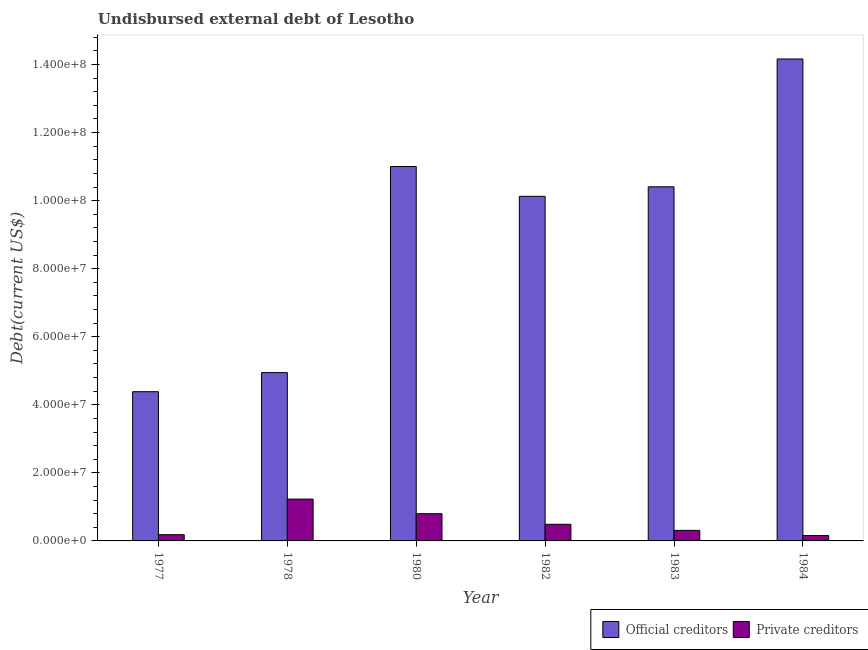Are the number of bars per tick equal to the number of legend labels?
Provide a succinct answer. Yes. Are the number of bars on each tick of the X-axis equal?
Your answer should be very brief. Yes. How many bars are there on the 6th tick from the left?
Provide a succinct answer. 2. What is the label of the 2nd group of bars from the left?
Give a very brief answer. 1978. What is the undisbursed external debt of official creditors in 1983?
Offer a terse response. 1.04e+08. Across all years, what is the maximum undisbursed external debt of official creditors?
Your answer should be compact. 1.42e+08. Across all years, what is the minimum undisbursed external debt of private creditors?
Offer a very short reply. 1.58e+06. In which year was the undisbursed external debt of private creditors maximum?
Your response must be concise. 1978. What is the total undisbursed external debt of private creditors in the graph?
Your answer should be compact. 3.17e+07. What is the difference between the undisbursed external debt of private creditors in 1978 and that in 1982?
Offer a very short reply. 7.40e+06. What is the difference between the undisbursed external debt of private creditors in 1980 and the undisbursed external debt of official creditors in 1982?
Give a very brief answer. 3.11e+06. What is the average undisbursed external debt of private creditors per year?
Offer a terse response. 5.28e+06. What is the ratio of the undisbursed external debt of official creditors in 1980 to that in 1984?
Provide a succinct answer. 0.78. Is the undisbursed external debt of private creditors in 1980 less than that in 1983?
Give a very brief answer. No. What is the difference between the highest and the second highest undisbursed external debt of private creditors?
Keep it short and to the point. 4.29e+06. What is the difference between the highest and the lowest undisbursed external debt of private creditors?
Your answer should be very brief. 1.07e+07. Is the sum of the undisbursed external debt of official creditors in 1983 and 1984 greater than the maximum undisbursed external debt of private creditors across all years?
Make the answer very short. Yes. What does the 1st bar from the left in 1982 represents?
Make the answer very short. Official creditors. What does the 2nd bar from the right in 1982 represents?
Keep it short and to the point. Official creditors. What is the difference between two consecutive major ticks on the Y-axis?
Make the answer very short. 2.00e+07. Are the values on the major ticks of Y-axis written in scientific E-notation?
Provide a succinct answer. Yes. Does the graph contain any zero values?
Give a very brief answer. No. Does the graph contain grids?
Your response must be concise. No. Where does the legend appear in the graph?
Make the answer very short. Bottom right. How many legend labels are there?
Your answer should be compact. 2. How are the legend labels stacked?
Provide a short and direct response. Horizontal. What is the title of the graph?
Ensure brevity in your answer.  Undisbursed external debt of Lesotho. What is the label or title of the Y-axis?
Your answer should be compact. Debt(current US$). What is the Debt(current US$) of Official creditors in 1977?
Your answer should be very brief. 4.39e+07. What is the Debt(current US$) of Private creditors in 1977?
Your response must be concise. 1.84e+06. What is the Debt(current US$) of Official creditors in 1978?
Provide a short and direct response. 4.95e+07. What is the Debt(current US$) of Private creditors in 1978?
Offer a very short reply. 1.23e+07. What is the Debt(current US$) in Official creditors in 1980?
Make the answer very short. 1.10e+08. What is the Debt(current US$) in Official creditors in 1982?
Provide a short and direct response. 1.01e+08. What is the Debt(current US$) of Private creditors in 1982?
Keep it short and to the point. 4.89e+06. What is the Debt(current US$) in Official creditors in 1983?
Make the answer very short. 1.04e+08. What is the Debt(current US$) of Private creditors in 1983?
Keep it short and to the point. 3.10e+06. What is the Debt(current US$) in Official creditors in 1984?
Your response must be concise. 1.42e+08. What is the Debt(current US$) in Private creditors in 1984?
Provide a short and direct response. 1.58e+06. Across all years, what is the maximum Debt(current US$) of Official creditors?
Provide a short and direct response. 1.42e+08. Across all years, what is the maximum Debt(current US$) of Private creditors?
Your answer should be compact. 1.23e+07. Across all years, what is the minimum Debt(current US$) in Official creditors?
Your response must be concise. 4.39e+07. Across all years, what is the minimum Debt(current US$) of Private creditors?
Offer a very short reply. 1.58e+06. What is the total Debt(current US$) in Official creditors in the graph?
Offer a terse response. 5.50e+08. What is the total Debt(current US$) of Private creditors in the graph?
Keep it short and to the point. 3.17e+07. What is the difference between the Debt(current US$) of Official creditors in 1977 and that in 1978?
Offer a terse response. -5.61e+06. What is the difference between the Debt(current US$) in Private creditors in 1977 and that in 1978?
Keep it short and to the point. -1.05e+07. What is the difference between the Debt(current US$) in Official creditors in 1977 and that in 1980?
Your response must be concise. -6.62e+07. What is the difference between the Debt(current US$) in Private creditors in 1977 and that in 1980?
Provide a succinct answer. -6.16e+06. What is the difference between the Debt(current US$) in Official creditors in 1977 and that in 1982?
Your answer should be very brief. -5.74e+07. What is the difference between the Debt(current US$) in Private creditors in 1977 and that in 1982?
Your response must be concise. -3.05e+06. What is the difference between the Debt(current US$) in Official creditors in 1977 and that in 1983?
Offer a very short reply. -6.02e+07. What is the difference between the Debt(current US$) in Private creditors in 1977 and that in 1983?
Offer a terse response. -1.26e+06. What is the difference between the Debt(current US$) in Official creditors in 1977 and that in 1984?
Offer a terse response. -9.78e+07. What is the difference between the Debt(current US$) of Private creditors in 1977 and that in 1984?
Keep it short and to the point. 2.59e+05. What is the difference between the Debt(current US$) in Official creditors in 1978 and that in 1980?
Provide a short and direct response. -6.06e+07. What is the difference between the Debt(current US$) in Private creditors in 1978 and that in 1980?
Keep it short and to the point. 4.29e+06. What is the difference between the Debt(current US$) in Official creditors in 1978 and that in 1982?
Give a very brief answer. -5.18e+07. What is the difference between the Debt(current US$) in Private creditors in 1978 and that in 1982?
Provide a short and direct response. 7.40e+06. What is the difference between the Debt(current US$) in Official creditors in 1978 and that in 1983?
Ensure brevity in your answer.  -5.46e+07. What is the difference between the Debt(current US$) of Private creditors in 1978 and that in 1983?
Provide a succinct answer. 9.19e+06. What is the difference between the Debt(current US$) of Official creditors in 1978 and that in 1984?
Your answer should be very brief. -9.22e+07. What is the difference between the Debt(current US$) of Private creditors in 1978 and that in 1984?
Provide a succinct answer. 1.07e+07. What is the difference between the Debt(current US$) of Official creditors in 1980 and that in 1982?
Offer a terse response. 8.77e+06. What is the difference between the Debt(current US$) in Private creditors in 1980 and that in 1982?
Offer a terse response. 3.11e+06. What is the difference between the Debt(current US$) of Official creditors in 1980 and that in 1983?
Provide a succinct answer. 5.97e+06. What is the difference between the Debt(current US$) of Private creditors in 1980 and that in 1983?
Offer a very short reply. 4.90e+06. What is the difference between the Debt(current US$) in Official creditors in 1980 and that in 1984?
Your answer should be very brief. -3.16e+07. What is the difference between the Debt(current US$) in Private creditors in 1980 and that in 1984?
Ensure brevity in your answer.  6.42e+06. What is the difference between the Debt(current US$) in Official creditors in 1982 and that in 1983?
Give a very brief answer. -2.80e+06. What is the difference between the Debt(current US$) in Private creditors in 1982 and that in 1983?
Provide a short and direct response. 1.79e+06. What is the difference between the Debt(current US$) in Official creditors in 1982 and that in 1984?
Your answer should be compact. -4.04e+07. What is the difference between the Debt(current US$) of Private creditors in 1982 and that in 1984?
Make the answer very short. 3.31e+06. What is the difference between the Debt(current US$) of Official creditors in 1983 and that in 1984?
Your answer should be very brief. -3.76e+07. What is the difference between the Debt(current US$) of Private creditors in 1983 and that in 1984?
Ensure brevity in your answer.  1.52e+06. What is the difference between the Debt(current US$) in Official creditors in 1977 and the Debt(current US$) in Private creditors in 1978?
Offer a terse response. 3.16e+07. What is the difference between the Debt(current US$) of Official creditors in 1977 and the Debt(current US$) of Private creditors in 1980?
Your answer should be very brief. 3.59e+07. What is the difference between the Debt(current US$) of Official creditors in 1977 and the Debt(current US$) of Private creditors in 1982?
Give a very brief answer. 3.90e+07. What is the difference between the Debt(current US$) in Official creditors in 1977 and the Debt(current US$) in Private creditors in 1983?
Ensure brevity in your answer.  4.08e+07. What is the difference between the Debt(current US$) in Official creditors in 1977 and the Debt(current US$) in Private creditors in 1984?
Provide a succinct answer. 4.23e+07. What is the difference between the Debt(current US$) of Official creditors in 1978 and the Debt(current US$) of Private creditors in 1980?
Your answer should be very brief. 4.15e+07. What is the difference between the Debt(current US$) of Official creditors in 1978 and the Debt(current US$) of Private creditors in 1982?
Your answer should be very brief. 4.46e+07. What is the difference between the Debt(current US$) of Official creditors in 1978 and the Debt(current US$) of Private creditors in 1983?
Ensure brevity in your answer.  4.64e+07. What is the difference between the Debt(current US$) in Official creditors in 1978 and the Debt(current US$) in Private creditors in 1984?
Your answer should be very brief. 4.79e+07. What is the difference between the Debt(current US$) in Official creditors in 1980 and the Debt(current US$) in Private creditors in 1982?
Offer a very short reply. 1.05e+08. What is the difference between the Debt(current US$) in Official creditors in 1980 and the Debt(current US$) in Private creditors in 1983?
Offer a terse response. 1.07e+08. What is the difference between the Debt(current US$) in Official creditors in 1980 and the Debt(current US$) in Private creditors in 1984?
Make the answer very short. 1.08e+08. What is the difference between the Debt(current US$) of Official creditors in 1982 and the Debt(current US$) of Private creditors in 1983?
Ensure brevity in your answer.  9.82e+07. What is the difference between the Debt(current US$) in Official creditors in 1982 and the Debt(current US$) in Private creditors in 1984?
Provide a short and direct response. 9.97e+07. What is the difference between the Debt(current US$) of Official creditors in 1983 and the Debt(current US$) of Private creditors in 1984?
Your answer should be very brief. 1.02e+08. What is the average Debt(current US$) in Official creditors per year?
Provide a short and direct response. 9.17e+07. What is the average Debt(current US$) in Private creditors per year?
Make the answer very short. 5.28e+06. In the year 1977, what is the difference between the Debt(current US$) in Official creditors and Debt(current US$) in Private creditors?
Keep it short and to the point. 4.20e+07. In the year 1978, what is the difference between the Debt(current US$) in Official creditors and Debt(current US$) in Private creditors?
Keep it short and to the point. 3.72e+07. In the year 1980, what is the difference between the Debt(current US$) in Official creditors and Debt(current US$) in Private creditors?
Keep it short and to the point. 1.02e+08. In the year 1982, what is the difference between the Debt(current US$) of Official creditors and Debt(current US$) of Private creditors?
Keep it short and to the point. 9.64e+07. In the year 1983, what is the difference between the Debt(current US$) in Official creditors and Debt(current US$) in Private creditors?
Give a very brief answer. 1.01e+08. In the year 1984, what is the difference between the Debt(current US$) in Official creditors and Debt(current US$) in Private creditors?
Give a very brief answer. 1.40e+08. What is the ratio of the Debt(current US$) in Official creditors in 1977 to that in 1978?
Keep it short and to the point. 0.89. What is the ratio of the Debt(current US$) of Private creditors in 1977 to that in 1978?
Give a very brief answer. 0.15. What is the ratio of the Debt(current US$) in Official creditors in 1977 to that in 1980?
Your answer should be compact. 0.4. What is the ratio of the Debt(current US$) of Private creditors in 1977 to that in 1980?
Make the answer very short. 0.23. What is the ratio of the Debt(current US$) in Official creditors in 1977 to that in 1982?
Give a very brief answer. 0.43. What is the ratio of the Debt(current US$) in Private creditors in 1977 to that in 1982?
Your answer should be compact. 0.38. What is the ratio of the Debt(current US$) of Official creditors in 1977 to that in 1983?
Ensure brevity in your answer.  0.42. What is the ratio of the Debt(current US$) in Private creditors in 1977 to that in 1983?
Offer a very short reply. 0.59. What is the ratio of the Debt(current US$) in Official creditors in 1977 to that in 1984?
Give a very brief answer. 0.31. What is the ratio of the Debt(current US$) of Private creditors in 1977 to that in 1984?
Keep it short and to the point. 1.16. What is the ratio of the Debt(current US$) of Official creditors in 1978 to that in 1980?
Provide a succinct answer. 0.45. What is the ratio of the Debt(current US$) of Private creditors in 1978 to that in 1980?
Offer a terse response. 1.54. What is the ratio of the Debt(current US$) in Official creditors in 1978 to that in 1982?
Make the answer very short. 0.49. What is the ratio of the Debt(current US$) of Private creditors in 1978 to that in 1982?
Give a very brief answer. 2.51. What is the ratio of the Debt(current US$) in Official creditors in 1978 to that in 1983?
Your answer should be very brief. 0.48. What is the ratio of the Debt(current US$) in Private creditors in 1978 to that in 1983?
Provide a succinct answer. 3.96. What is the ratio of the Debt(current US$) of Official creditors in 1978 to that in 1984?
Your answer should be very brief. 0.35. What is the ratio of the Debt(current US$) of Private creditors in 1978 to that in 1984?
Ensure brevity in your answer.  7.77. What is the ratio of the Debt(current US$) in Official creditors in 1980 to that in 1982?
Offer a very short reply. 1.09. What is the ratio of the Debt(current US$) in Private creditors in 1980 to that in 1982?
Your answer should be compact. 1.64. What is the ratio of the Debt(current US$) in Official creditors in 1980 to that in 1983?
Your response must be concise. 1.06. What is the ratio of the Debt(current US$) of Private creditors in 1980 to that in 1983?
Ensure brevity in your answer.  2.58. What is the ratio of the Debt(current US$) in Official creditors in 1980 to that in 1984?
Offer a terse response. 0.78. What is the ratio of the Debt(current US$) of Private creditors in 1980 to that in 1984?
Give a very brief answer. 5.06. What is the ratio of the Debt(current US$) in Official creditors in 1982 to that in 1983?
Ensure brevity in your answer.  0.97. What is the ratio of the Debt(current US$) in Private creditors in 1982 to that in 1983?
Keep it short and to the point. 1.58. What is the ratio of the Debt(current US$) in Official creditors in 1982 to that in 1984?
Offer a very short reply. 0.71. What is the ratio of the Debt(current US$) in Private creditors in 1982 to that in 1984?
Your answer should be compact. 3.09. What is the ratio of the Debt(current US$) of Official creditors in 1983 to that in 1984?
Offer a very short reply. 0.73. What is the ratio of the Debt(current US$) of Private creditors in 1983 to that in 1984?
Your answer should be compact. 1.96. What is the difference between the highest and the second highest Debt(current US$) in Official creditors?
Provide a short and direct response. 3.16e+07. What is the difference between the highest and the second highest Debt(current US$) in Private creditors?
Provide a succinct answer. 4.29e+06. What is the difference between the highest and the lowest Debt(current US$) of Official creditors?
Provide a short and direct response. 9.78e+07. What is the difference between the highest and the lowest Debt(current US$) of Private creditors?
Provide a short and direct response. 1.07e+07. 